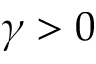Convert formula to latex. <formula><loc_0><loc_0><loc_500><loc_500>\gamma > 0</formula> 